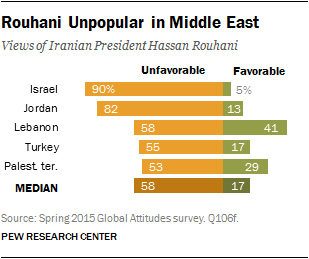Specify some key components in this picture. A recent survey in Jordan revealed that only 13% of the people surveyed hold a favorable view of Iranian President Hassan Rouhani. In just 3 countries, fewer than 20% of the population holds a favorable view of Iranian President Hassan Rouhani. 